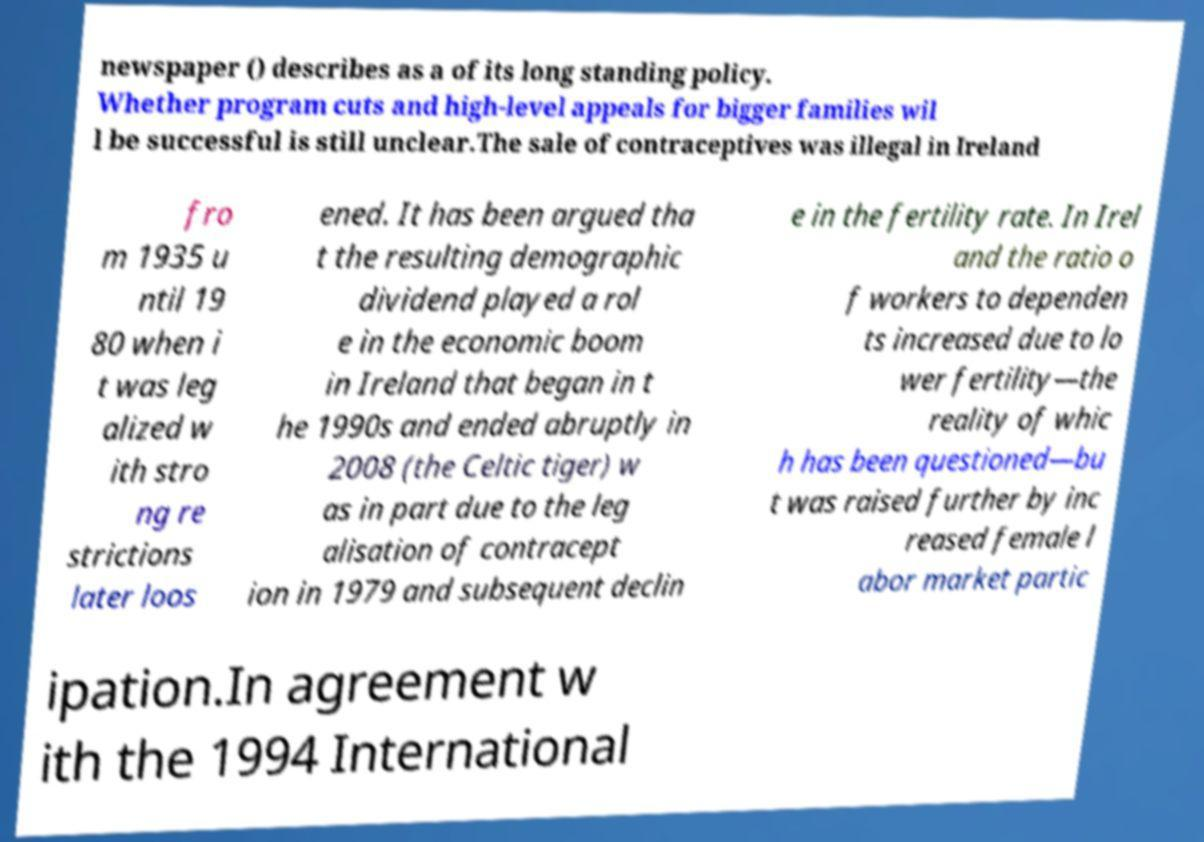What messages or text are displayed in this image? I need them in a readable, typed format. newspaper () describes as a of its long standing policy. Whether program cuts and high-level appeals for bigger families wil l be successful is still unclear.The sale of contraceptives was illegal in Ireland fro m 1935 u ntil 19 80 when i t was leg alized w ith stro ng re strictions later loos ened. It has been argued tha t the resulting demographic dividend played a rol e in the economic boom in Ireland that began in t he 1990s and ended abruptly in 2008 (the Celtic tiger) w as in part due to the leg alisation of contracept ion in 1979 and subsequent declin e in the fertility rate. In Irel and the ratio o f workers to dependen ts increased due to lo wer fertility—the reality of whic h has been questioned—bu t was raised further by inc reased female l abor market partic ipation.In agreement w ith the 1994 International 